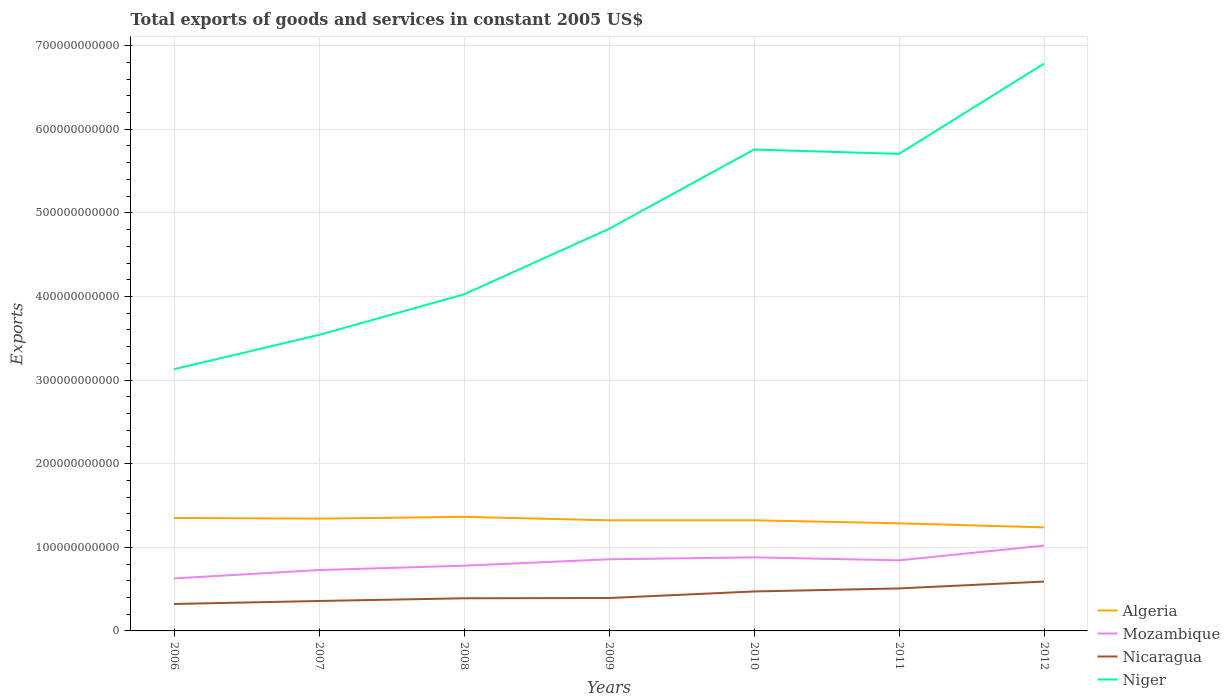How many different coloured lines are there?
Give a very brief answer. 4. Is the number of lines equal to the number of legend labels?
Keep it short and to the point. Yes. Across all years, what is the maximum total exports of goods and services in Mozambique?
Your response must be concise. 6.28e+1. What is the total total exports of goods and services in Niger in the graph?
Offer a terse response. 5.21e+09. What is the difference between the highest and the second highest total exports of goods and services in Algeria?
Provide a succinct answer. 1.26e+1. How many years are there in the graph?
Offer a very short reply. 7. What is the difference between two consecutive major ticks on the Y-axis?
Provide a short and direct response. 1.00e+11. Are the values on the major ticks of Y-axis written in scientific E-notation?
Keep it short and to the point. No. Where does the legend appear in the graph?
Ensure brevity in your answer.  Bottom right. How are the legend labels stacked?
Offer a terse response. Vertical. What is the title of the graph?
Offer a terse response. Total exports of goods and services in constant 2005 US$. Does "American Samoa" appear as one of the legend labels in the graph?
Your answer should be compact. No. What is the label or title of the X-axis?
Provide a short and direct response. Years. What is the label or title of the Y-axis?
Your answer should be compact. Exports. What is the Exports in Algeria in 2006?
Ensure brevity in your answer.  1.35e+11. What is the Exports of Mozambique in 2006?
Your response must be concise. 6.28e+1. What is the Exports of Nicaragua in 2006?
Offer a very short reply. 3.22e+1. What is the Exports in Niger in 2006?
Offer a very short reply. 3.13e+11. What is the Exports of Algeria in 2007?
Keep it short and to the point. 1.34e+11. What is the Exports of Mozambique in 2007?
Offer a very short reply. 7.28e+1. What is the Exports of Nicaragua in 2007?
Offer a terse response. 3.58e+1. What is the Exports of Niger in 2007?
Provide a succinct answer. 3.54e+11. What is the Exports of Algeria in 2008?
Give a very brief answer. 1.36e+11. What is the Exports of Mozambique in 2008?
Keep it short and to the point. 7.80e+1. What is the Exports in Nicaragua in 2008?
Your response must be concise. 3.90e+1. What is the Exports of Niger in 2008?
Offer a terse response. 4.03e+11. What is the Exports in Algeria in 2009?
Make the answer very short. 1.32e+11. What is the Exports in Mozambique in 2009?
Provide a short and direct response. 8.57e+1. What is the Exports in Nicaragua in 2009?
Ensure brevity in your answer.  3.93e+1. What is the Exports in Niger in 2009?
Ensure brevity in your answer.  4.81e+11. What is the Exports of Algeria in 2010?
Provide a short and direct response. 1.32e+11. What is the Exports of Mozambique in 2010?
Keep it short and to the point. 8.80e+1. What is the Exports in Nicaragua in 2010?
Your response must be concise. 4.72e+1. What is the Exports of Niger in 2010?
Give a very brief answer. 5.76e+11. What is the Exports of Algeria in 2011?
Your answer should be very brief. 1.29e+11. What is the Exports in Mozambique in 2011?
Your answer should be very brief. 8.45e+1. What is the Exports of Nicaragua in 2011?
Give a very brief answer. 5.08e+1. What is the Exports of Niger in 2011?
Ensure brevity in your answer.  5.71e+11. What is the Exports of Algeria in 2012?
Make the answer very short. 1.24e+11. What is the Exports of Mozambique in 2012?
Offer a terse response. 1.02e+11. What is the Exports in Nicaragua in 2012?
Provide a succinct answer. 5.90e+1. What is the Exports in Niger in 2012?
Offer a terse response. 6.78e+11. Across all years, what is the maximum Exports of Algeria?
Your answer should be compact. 1.36e+11. Across all years, what is the maximum Exports of Mozambique?
Provide a short and direct response. 1.02e+11. Across all years, what is the maximum Exports in Nicaragua?
Make the answer very short. 5.90e+1. Across all years, what is the maximum Exports in Niger?
Your response must be concise. 6.78e+11. Across all years, what is the minimum Exports of Algeria?
Give a very brief answer. 1.24e+11. Across all years, what is the minimum Exports in Mozambique?
Your response must be concise. 6.28e+1. Across all years, what is the minimum Exports in Nicaragua?
Your response must be concise. 3.22e+1. Across all years, what is the minimum Exports of Niger?
Offer a terse response. 3.13e+11. What is the total Exports in Algeria in the graph?
Provide a succinct answer. 9.23e+11. What is the total Exports in Mozambique in the graph?
Your response must be concise. 5.74e+11. What is the total Exports of Nicaragua in the graph?
Your response must be concise. 3.03e+11. What is the total Exports in Niger in the graph?
Offer a terse response. 3.38e+12. What is the difference between the Exports in Algeria in 2006 and that in 2007?
Keep it short and to the point. 8.11e+08. What is the difference between the Exports in Mozambique in 2006 and that in 2007?
Your response must be concise. -1.00e+1. What is the difference between the Exports of Nicaragua in 2006 and that in 2007?
Make the answer very short. -3.57e+09. What is the difference between the Exports of Niger in 2006 and that in 2007?
Your answer should be compact. -4.11e+1. What is the difference between the Exports of Algeria in 2006 and that in 2008?
Your answer should be very brief. -1.34e+09. What is the difference between the Exports of Mozambique in 2006 and that in 2008?
Offer a terse response. -1.52e+1. What is the difference between the Exports of Nicaragua in 2006 and that in 2008?
Your response must be concise. -6.80e+09. What is the difference between the Exports of Niger in 2006 and that in 2008?
Ensure brevity in your answer.  -8.96e+1. What is the difference between the Exports in Algeria in 2006 and that in 2009?
Provide a short and direct response. 2.81e+09. What is the difference between the Exports of Mozambique in 2006 and that in 2009?
Keep it short and to the point. -2.29e+1. What is the difference between the Exports in Nicaragua in 2006 and that in 2009?
Your response must be concise. -7.11e+09. What is the difference between the Exports of Niger in 2006 and that in 2009?
Provide a short and direct response. -1.68e+11. What is the difference between the Exports in Algeria in 2006 and that in 2010?
Offer a terse response. 2.81e+09. What is the difference between the Exports in Mozambique in 2006 and that in 2010?
Your response must be concise. -2.52e+1. What is the difference between the Exports in Nicaragua in 2006 and that in 2010?
Provide a succinct answer. -1.49e+1. What is the difference between the Exports in Niger in 2006 and that in 2010?
Ensure brevity in your answer.  -2.63e+11. What is the difference between the Exports of Algeria in 2006 and that in 2011?
Your answer should be very brief. 6.38e+09. What is the difference between the Exports of Mozambique in 2006 and that in 2011?
Keep it short and to the point. -2.17e+1. What is the difference between the Exports of Nicaragua in 2006 and that in 2011?
Ensure brevity in your answer.  -1.86e+1. What is the difference between the Exports of Niger in 2006 and that in 2011?
Keep it short and to the point. -2.58e+11. What is the difference between the Exports of Algeria in 2006 and that in 2012?
Make the answer very short. 1.13e+1. What is the difference between the Exports of Mozambique in 2006 and that in 2012?
Provide a short and direct response. -3.92e+1. What is the difference between the Exports in Nicaragua in 2006 and that in 2012?
Give a very brief answer. -2.68e+1. What is the difference between the Exports in Niger in 2006 and that in 2012?
Your answer should be very brief. -3.66e+11. What is the difference between the Exports of Algeria in 2007 and that in 2008?
Your answer should be compact. -2.15e+09. What is the difference between the Exports in Mozambique in 2007 and that in 2008?
Ensure brevity in your answer.  -5.20e+09. What is the difference between the Exports in Nicaragua in 2007 and that in 2008?
Make the answer very short. -3.23e+09. What is the difference between the Exports of Niger in 2007 and that in 2008?
Give a very brief answer. -4.85e+1. What is the difference between the Exports of Algeria in 2007 and that in 2009?
Offer a terse response. 2.00e+09. What is the difference between the Exports in Mozambique in 2007 and that in 2009?
Your answer should be very brief. -1.29e+1. What is the difference between the Exports in Nicaragua in 2007 and that in 2009?
Keep it short and to the point. -3.54e+09. What is the difference between the Exports in Niger in 2007 and that in 2009?
Offer a terse response. -1.27e+11. What is the difference between the Exports of Algeria in 2007 and that in 2010?
Give a very brief answer. 2.00e+09. What is the difference between the Exports in Mozambique in 2007 and that in 2010?
Give a very brief answer. -1.52e+1. What is the difference between the Exports in Nicaragua in 2007 and that in 2010?
Your response must be concise. -1.14e+1. What is the difference between the Exports in Niger in 2007 and that in 2010?
Offer a terse response. -2.22e+11. What is the difference between the Exports of Algeria in 2007 and that in 2011?
Your answer should be compact. 5.57e+09. What is the difference between the Exports of Mozambique in 2007 and that in 2011?
Make the answer very short. -1.17e+1. What is the difference between the Exports in Nicaragua in 2007 and that in 2011?
Your answer should be very brief. -1.50e+1. What is the difference between the Exports in Niger in 2007 and that in 2011?
Offer a very short reply. -2.16e+11. What is the difference between the Exports in Algeria in 2007 and that in 2012?
Your answer should be very brief. 1.05e+1. What is the difference between the Exports in Mozambique in 2007 and that in 2012?
Keep it short and to the point. -2.92e+1. What is the difference between the Exports in Nicaragua in 2007 and that in 2012?
Your answer should be very brief. -2.32e+1. What is the difference between the Exports of Niger in 2007 and that in 2012?
Your response must be concise. -3.24e+11. What is the difference between the Exports of Algeria in 2008 and that in 2009?
Provide a short and direct response. 4.15e+09. What is the difference between the Exports in Mozambique in 2008 and that in 2009?
Offer a very short reply. -7.68e+09. What is the difference between the Exports of Nicaragua in 2008 and that in 2009?
Offer a very short reply. -3.12e+08. What is the difference between the Exports of Niger in 2008 and that in 2009?
Ensure brevity in your answer.  -7.83e+1. What is the difference between the Exports of Algeria in 2008 and that in 2010?
Make the answer very short. 4.15e+09. What is the difference between the Exports of Mozambique in 2008 and that in 2010?
Your response must be concise. -1.00e+1. What is the difference between the Exports in Nicaragua in 2008 and that in 2010?
Provide a succinct answer. -8.14e+09. What is the difference between the Exports of Niger in 2008 and that in 2010?
Give a very brief answer. -1.73e+11. What is the difference between the Exports in Algeria in 2008 and that in 2011?
Provide a succinct answer. 7.72e+09. What is the difference between the Exports in Mozambique in 2008 and that in 2011?
Give a very brief answer. -6.46e+09. What is the difference between the Exports of Nicaragua in 2008 and that in 2011?
Offer a terse response. -1.18e+1. What is the difference between the Exports of Niger in 2008 and that in 2011?
Your answer should be compact. -1.68e+11. What is the difference between the Exports in Algeria in 2008 and that in 2012?
Make the answer very short. 1.26e+1. What is the difference between the Exports of Mozambique in 2008 and that in 2012?
Keep it short and to the point. -2.40e+1. What is the difference between the Exports in Nicaragua in 2008 and that in 2012?
Provide a succinct answer. -2.00e+1. What is the difference between the Exports of Niger in 2008 and that in 2012?
Your answer should be very brief. -2.76e+11. What is the difference between the Exports of Algeria in 2009 and that in 2010?
Ensure brevity in your answer.  0. What is the difference between the Exports in Mozambique in 2009 and that in 2010?
Keep it short and to the point. -2.32e+09. What is the difference between the Exports in Nicaragua in 2009 and that in 2010?
Offer a terse response. -7.83e+09. What is the difference between the Exports in Niger in 2009 and that in 2010?
Provide a succinct answer. -9.49e+1. What is the difference between the Exports of Algeria in 2009 and that in 2011?
Give a very brief answer. 3.57e+09. What is the difference between the Exports of Mozambique in 2009 and that in 2011?
Provide a succinct answer. 1.22e+09. What is the difference between the Exports in Nicaragua in 2009 and that in 2011?
Ensure brevity in your answer.  -1.15e+1. What is the difference between the Exports in Niger in 2009 and that in 2011?
Provide a succinct answer. -8.97e+1. What is the difference between the Exports in Algeria in 2009 and that in 2012?
Give a very brief answer. 8.46e+09. What is the difference between the Exports of Mozambique in 2009 and that in 2012?
Your answer should be very brief. -1.64e+1. What is the difference between the Exports in Nicaragua in 2009 and that in 2012?
Ensure brevity in your answer.  -1.97e+1. What is the difference between the Exports in Niger in 2009 and that in 2012?
Give a very brief answer. -1.98e+11. What is the difference between the Exports in Algeria in 2010 and that in 2011?
Provide a succinct answer. 3.57e+09. What is the difference between the Exports of Mozambique in 2010 and that in 2011?
Give a very brief answer. 3.54e+09. What is the difference between the Exports of Nicaragua in 2010 and that in 2011?
Provide a short and direct response. -3.65e+09. What is the difference between the Exports of Niger in 2010 and that in 2011?
Keep it short and to the point. 5.21e+09. What is the difference between the Exports in Algeria in 2010 and that in 2012?
Your answer should be compact. 8.46e+09. What is the difference between the Exports in Mozambique in 2010 and that in 2012?
Provide a short and direct response. -1.40e+1. What is the difference between the Exports of Nicaragua in 2010 and that in 2012?
Offer a terse response. -1.19e+1. What is the difference between the Exports in Niger in 2010 and that in 2012?
Keep it short and to the point. -1.03e+11. What is the difference between the Exports in Algeria in 2011 and that in 2012?
Offer a terse response. 4.89e+09. What is the difference between the Exports of Mozambique in 2011 and that in 2012?
Offer a very short reply. -1.76e+1. What is the difference between the Exports of Nicaragua in 2011 and that in 2012?
Provide a short and direct response. -8.22e+09. What is the difference between the Exports of Niger in 2011 and that in 2012?
Offer a very short reply. -1.08e+11. What is the difference between the Exports of Algeria in 2006 and the Exports of Mozambique in 2007?
Keep it short and to the point. 6.23e+1. What is the difference between the Exports in Algeria in 2006 and the Exports in Nicaragua in 2007?
Give a very brief answer. 9.93e+1. What is the difference between the Exports of Algeria in 2006 and the Exports of Niger in 2007?
Your answer should be very brief. -2.19e+11. What is the difference between the Exports of Mozambique in 2006 and the Exports of Nicaragua in 2007?
Provide a short and direct response. 2.70e+1. What is the difference between the Exports in Mozambique in 2006 and the Exports in Niger in 2007?
Your answer should be very brief. -2.91e+11. What is the difference between the Exports in Nicaragua in 2006 and the Exports in Niger in 2007?
Give a very brief answer. -3.22e+11. What is the difference between the Exports in Algeria in 2006 and the Exports in Mozambique in 2008?
Offer a very short reply. 5.71e+1. What is the difference between the Exports of Algeria in 2006 and the Exports of Nicaragua in 2008?
Ensure brevity in your answer.  9.61e+1. What is the difference between the Exports of Algeria in 2006 and the Exports of Niger in 2008?
Offer a very short reply. -2.67e+11. What is the difference between the Exports in Mozambique in 2006 and the Exports in Nicaragua in 2008?
Make the answer very short. 2.38e+1. What is the difference between the Exports in Mozambique in 2006 and the Exports in Niger in 2008?
Offer a terse response. -3.40e+11. What is the difference between the Exports of Nicaragua in 2006 and the Exports of Niger in 2008?
Make the answer very short. -3.70e+11. What is the difference between the Exports in Algeria in 2006 and the Exports in Mozambique in 2009?
Your answer should be very brief. 4.94e+1. What is the difference between the Exports of Algeria in 2006 and the Exports of Nicaragua in 2009?
Give a very brief answer. 9.58e+1. What is the difference between the Exports of Algeria in 2006 and the Exports of Niger in 2009?
Your answer should be very brief. -3.46e+11. What is the difference between the Exports of Mozambique in 2006 and the Exports of Nicaragua in 2009?
Your answer should be compact. 2.34e+1. What is the difference between the Exports of Mozambique in 2006 and the Exports of Niger in 2009?
Your answer should be very brief. -4.18e+11. What is the difference between the Exports in Nicaragua in 2006 and the Exports in Niger in 2009?
Offer a very short reply. -4.49e+11. What is the difference between the Exports of Algeria in 2006 and the Exports of Mozambique in 2010?
Provide a succinct answer. 4.71e+1. What is the difference between the Exports of Algeria in 2006 and the Exports of Nicaragua in 2010?
Your answer should be very brief. 8.79e+1. What is the difference between the Exports of Algeria in 2006 and the Exports of Niger in 2010?
Offer a terse response. -4.41e+11. What is the difference between the Exports in Mozambique in 2006 and the Exports in Nicaragua in 2010?
Make the answer very short. 1.56e+1. What is the difference between the Exports of Mozambique in 2006 and the Exports of Niger in 2010?
Provide a short and direct response. -5.13e+11. What is the difference between the Exports of Nicaragua in 2006 and the Exports of Niger in 2010?
Give a very brief answer. -5.43e+11. What is the difference between the Exports of Algeria in 2006 and the Exports of Mozambique in 2011?
Your response must be concise. 5.06e+1. What is the difference between the Exports in Algeria in 2006 and the Exports in Nicaragua in 2011?
Offer a terse response. 8.43e+1. What is the difference between the Exports in Algeria in 2006 and the Exports in Niger in 2011?
Your answer should be very brief. -4.35e+11. What is the difference between the Exports of Mozambique in 2006 and the Exports of Nicaragua in 2011?
Provide a short and direct response. 1.20e+1. What is the difference between the Exports of Mozambique in 2006 and the Exports of Niger in 2011?
Give a very brief answer. -5.08e+11. What is the difference between the Exports of Nicaragua in 2006 and the Exports of Niger in 2011?
Your answer should be compact. -5.38e+11. What is the difference between the Exports of Algeria in 2006 and the Exports of Mozambique in 2012?
Make the answer very short. 3.31e+1. What is the difference between the Exports of Algeria in 2006 and the Exports of Nicaragua in 2012?
Keep it short and to the point. 7.61e+1. What is the difference between the Exports in Algeria in 2006 and the Exports in Niger in 2012?
Give a very brief answer. -5.43e+11. What is the difference between the Exports of Mozambique in 2006 and the Exports of Nicaragua in 2012?
Provide a short and direct response. 3.75e+09. What is the difference between the Exports of Mozambique in 2006 and the Exports of Niger in 2012?
Your answer should be very brief. -6.16e+11. What is the difference between the Exports in Nicaragua in 2006 and the Exports in Niger in 2012?
Give a very brief answer. -6.46e+11. What is the difference between the Exports in Algeria in 2007 and the Exports in Mozambique in 2008?
Offer a very short reply. 5.63e+1. What is the difference between the Exports of Algeria in 2007 and the Exports of Nicaragua in 2008?
Your answer should be compact. 9.53e+1. What is the difference between the Exports of Algeria in 2007 and the Exports of Niger in 2008?
Ensure brevity in your answer.  -2.68e+11. What is the difference between the Exports in Mozambique in 2007 and the Exports in Nicaragua in 2008?
Make the answer very short. 3.38e+1. What is the difference between the Exports of Mozambique in 2007 and the Exports of Niger in 2008?
Give a very brief answer. -3.30e+11. What is the difference between the Exports of Nicaragua in 2007 and the Exports of Niger in 2008?
Give a very brief answer. -3.67e+11. What is the difference between the Exports of Algeria in 2007 and the Exports of Mozambique in 2009?
Make the answer very short. 4.86e+1. What is the difference between the Exports in Algeria in 2007 and the Exports in Nicaragua in 2009?
Your answer should be compact. 9.49e+1. What is the difference between the Exports in Algeria in 2007 and the Exports in Niger in 2009?
Give a very brief answer. -3.47e+11. What is the difference between the Exports in Mozambique in 2007 and the Exports in Nicaragua in 2009?
Offer a terse response. 3.34e+1. What is the difference between the Exports of Mozambique in 2007 and the Exports of Niger in 2009?
Make the answer very short. -4.08e+11. What is the difference between the Exports in Nicaragua in 2007 and the Exports in Niger in 2009?
Your answer should be compact. -4.45e+11. What is the difference between the Exports in Algeria in 2007 and the Exports in Mozambique in 2010?
Provide a short and direct response. 4.63e+1. What is the difference between the Exports of Algeria in 2007 and the Exports of Nicaragua in 2010?
Provide a short and direct response. 8.71e+1. What is the difference between the Exports in Algeria in 2007 and the Exports in Niger in 2010?
Make the answer very short. -4.41e+11. What is the difference between the Exports of Mozambique in 2007 and the Exports of Nicaragua in 2010?
Your answer should be compact. 2.56e+1. What is the difference between the Exports in Mozambique in 2007 and the Exports in Niger in 2010?
Offer a terse response. -5.03e+11. What is the difference between the Exports of Nicaragua in 2007 and the Exports of Niger in 2010?
Provide a succinct answer. -5.40e+11. What is the difference between the Exports in Algeria in 2007 and the Exports in Mozambique in 2011?
Your answer should be compact. 4.98e+1. What is the difference between the Exports in Algeria in 2007 and the Exports in Nicaragua in 2011?
Provide a short and direct response. 8.35e+1. What is the difference between the Exports in Algeria in 2007 and the Exports in Niger in 2011?
Make the answer very short. -4.36e+11. What is the difference between the Exports in Mozambique in 2007 and the Exports in Nicaragua in 2011?
Provide a succinct answer. 2.20e+1. What is the difference between the Exports of Mozambique in 2007 and the Exports of Niger in 2011?
Your answer should be compact. -4.98e+11. What is the difference between the Exports of Nicaragua in 2007 and the Exports of Niger in 2011?
Give a very brief answer. -5.35e+11. What is the difference between the Exports in Algeria in 2007 and the Exports in Mozambique in 2012?
Provide a succinct answer. 3.23e+1. What is the difference between the Exports of Algeria in 2007 and the Exports of Nicaragua in 2012?
Offer a terse response. 7.52e+1. What is the difference between the Exports in Algeria in 2007 and the Exports in Niger in 2012?
Your response must be concise. -5.44e+11. What is the difference between the Exports in Mozambique in 2007 and the Exports in Nicaragua in 2012?
Ensure brevity in your answer.  1.38e+1. What is the difference between the Exports in Mozambique in 2007 and the Exports in Niger in 2012?
Provide a succinct answer. -6.06e+11. What is the difference between the Exports in Nicaragua in 2007 and the Exports in Niger in 2012?
Your answer should be very brief. -6.43e+11. What is the difference between the Exports of Algeria in 2008 and the Exports of Mozambique in 2009?
Offer a terse response. 5.08e+1. What is the difference between the Exports in Algeria in 2008 and the Exports in Nicaragua in 2009?
Your response must be concise. 9.71e+1. What is the difference between the Exports of Algeria in 2008 and the Exports of Niger in 2009?
Make the answer very short. -3.44e+11. What is the difference between the Exports of Mozambique in 2008 and the Exports of Nicaragua in 2009?
Make the answer very short. 3.86e+1. What is the difference between the Exports of Mozambique in 2008 and the Exports of Niger in 2009?
Provide a short and direct response. -4.03e+11. What is the difference between the Exports in Nicaragua in 2008 and the Exports in Niger in 2009?
Offer a terse response. -4.42e+11. What is the difference between the Exports of Algeria in 2008 and the Exports of Mozambique in 2010?
Your answer should be very brief. 4.85e+1. What is the difference between the Exports of Algeria in 2008 and the Exports of Nicaragua in 2010?
Your answer should be compact. 8.93e+1. What is the difference between the Exports in Algeria in 2008 and the Exports in Niger in 2010?
Give a very brief answer. -4.39e+11. What is the difference between the Exports in Mozambique in 2008 and the Exports in Nicaragua in 2010?
Your answer should be very brief. 3.08e+1. What is the difference between the Exports in Mozambique in 2008 and the Exports in Niger in 2010?
Your answer should be very brief. -4.98e+11. What is the difference between the Exports of Nicaragua in 2008 and the Exports of Niger in 2010?
Keep it short and to the point. -5.37e+11. What is the difference between the Exports of Algeria in 2008 and the Exports of Mozambique in 2011?
Give a very brief answer. 5.20e+1. What is the difference between the Exports in Algeria in 2008 and the Exports in Nicaragua in 2011?
Make the answer very short. 8.56e+1. What is the difference between the Exports in Algeria in 2008 and the Exports in Niger in 2011?
Provide a short and direct response. -4.34e+11. What is the difference between the Exports in Mozambique in 2008 and the Exports in Nicaragua in 2011?
Give a very brief answer. 2.72e+1. What is the difference between the Exports in Mozambique in 2008 and the Exports in Niger in 2011?
Ensure brevity in your answer.  -4.93e+11. What is the difference between the Exports of Nicaragua in 2008 and the Exports of Niger in 2011?
Provide a succinct answer. -5.31e+11. What is the difference between the Exports in Algeria in 2008 and the Exports in Mozambique in 2012?
Offer a very short reply. 3.44e+1. What is the difference between the Exports in Algeria in 2008 and the Exports in Nicaragua in 2012?
Give a very brief answer. 7.74e+1. What is the difference between the Exports of Algeria in 2008 and the Exports of Niger in 2012?
Offer a terse response. -5.42e+11. What is the difference between the Exports in Mozambique in 2008 and the Exports in Nicaragua in 2012?
Ensure brevity in your answer.  1.89e+1. What is the difference between the Exports of Mozambique in 2008 and the Exports of Niger in 2012?
Offer a terse response. -6.01e+11. What is the difference between the Exports in Nicaragua in 2008 and the Exports in Niger in 2012?
Offer a terse response. -6.39e+11. What is the difference between the Exports in Algeria in 2009 and the Exports in Mozambique in 2010?
Keep it short and to the point. 4.43e+1. What is the difference between the Exports of Algeria in 2009 and the Exports of Nicaragua in 2010?
Offer a terse response. 8.51e+1. What is the difference between the Exports in Algeria in 2009 and the Exports in Niger in 2010?
Keep it short and to the point. -4.43e+11. What is the difference between the Exports of Mozambique in 2009 and the Exports of Nicaragua in 2010?
Offer a terse response. 3.85e+1. What is the difference between the Exports in Mozambique in 2009 and the Exports in Niger in 2010?
Make the answer very short. -4.90e+11. What is the difference between the Exports in Nicaragua in 2009 and the Exports in Niger in 2010?
Make the answer very short. -5.36e+11. What is the difference between the Exports of Algeria in 2009 and the Exports of Mozambique in 2011?
Your response must be concise. 4.78e+1. What is the difference between the Exports in Algeria in 2009 and the Exports in Nicaragua in 2011?
Your answer should be very brief. 8.15e+1. What is the difference between the Exports in Algeria in 2009 and the Exports in Niger in 2011?
Provide a short and direct response. -4.38e+11. What is the difference between the Exports in Mozambique in 2009 and the Exports in Nicaragua in 2011?
Your answer should be compact. 3.48e+1. What is the difference between the Exports in Mozambique in 2009 and the Exports in Niger in 2011?
Give a very brief answer. -4.85e+11. What is the difference between the Exports in Nicaragua in 2009 and the Exports in Niger in 2011?
Ensure brevity in your answer.  -5.31e+11. What is the difference between the Exports in Algeria in 2009 and the Exports in Mozambique in 2012?
Keep it short and to the point. 3.03e+1. What is the difference between the Exports of Algeria in 2009 and the Exports of Nicaragua in 2012?
Your answer should be very brief. 7.32e+1. What is the difference between the Exports of Algeria in 2009 and the Exports of Niger in 2012?
Provide a short and direct response. -5.46e+11. What is the difference between the Exports of Mozambique in 2009 and the Exports of Nicaragua in 2012?
Offer a very short reply. 2.66e+1. What is the difference between the Exports in Mozambique in 2009 and the Exports in Niger in 2012?
Provide a short and direct response. -5.93e+11. What is the difference between the Exports in Nicaragua in 2009 and the Exports in Niger in 2012?
Provide a succinct answer. -6.39e+11. What is the difference between the Exports of Algeria in 2010 and the Exports of Mozambique in 2011?
Offer a terse response. 4.78e+1. What is the difference between the Exports of Algeria in 2010 and the Exports of Nicaragua in 2011?
Provide a short and direct response. 8.15e+1. What is the difference between the Exports of Algeria in 2010 and the Exports of Niger in 2011?
Keep it short and to the point. -4.38e+11. What is the difference between the Exports of Mozambique in 2010 and the Exports of Nicaragua in 2011?
Give a very brief answer. 3.72e+1. What is the difference between the Exports of Mozambique in 2010 and the Exports of Niger in 2011?
Your answer should be very brief. -4.83e+11. What is the difference between the Exports in Nicaragua in 2010 and the Exports in Niger in 2011?
Make the answer very short. -5.23e+11. What is the difference between the Exports of Algeria in 2010 and the Exports of Mozambique in 2012?
Give a very brief answer. 3.03e+1. What is the difference between the Exports in Algeria in 2010 and the Exports in Nicaragua in 2012?
Make the answer very short. 7.32e+1. What is the difference between the Exports of Algeria in 2010 and the Exports of Niger in 2012?
Make the answer very short. -5.46e+11. What is the difference between the Exports in Mozambique in 2010 and the Exports in Nicaragua in 2012?
Give a very brief answer. 2.89e+1. What is the difference between the Exports in Mozambique in 2010 and the Exports in Niger in 2012?
Provide a succinct answer. -5.91e+11. What is the difference between the Exports in Nicaragua in 2010 and the Exports in Niger in 2012?
Offer a very short reply. -6.31e+11. What is the difference between the Exports in Algeria in 2011 and the Exports in Mozambique in 2012?
Provide a short and direct response. 2.67e+1. What is the difference between the Exports of Algeria in 2011 and the Exports of Nicaragua in 2012?
Provide a succinct answer. 6.97e+1. What is the difference between the Exports of Algeria in 2011 and the Exports of Niger in 2012?
Make the answer very short. -5.50e+11. What is the difference between the Exports of Mozambique in 2011 and the Exports of Nicaragua in 2012?
Give a very brief answer. 2.54e+1. What is the difference between the Exports in Mozambique in 2011 and the Exports in Niger in 2012?
Provide a succinct answer. -5.94e+11. What is the difference between the Exports of Nicaragua in 2011 and the Exports of Niger in 2012?
Give a very brief answer. -6.28e+11. What is the average Exports of Algeria per year?
Your response must be concise. 1.32e+11. What is the average Exports in Mozambique per year?
Provide a short and direct response. 8.20e+1. What is the average Exports of Nicaragua per year?
Give a very brief answer. 4.34e+1. What is the average Exports of Niger per year?
Make the answer very short. 4.82e+11. In the year 2006, what is the difference between the Exports in Algeria and Exports in Mozambique?
Ensure brevity in your answer.  7.23e+1. In the year 2006, what is the difference between the Exports in Algeria and Exports in Nicaragua?
Give a very brief answer. 1.03e+11. In the year 2006, what is the difference between the Exports in Algeria and Exports in Niger?
Provide a succinct answer. -1.78e+11. In the year 2006, what is the difference between the Exports in Mozambique and Exports in Nicaragua?
Offer a very short reply. 3.06e+1. In the year 2006, what is the difference between the Exports of Mozambique and Exports of Niger?
Offer a very short reply. -2.50e+11. In the year 2006, what is the difference between the Exports in Nicaragua and Exports in Niger?
Give a very brief answer. -2.81e+11. In the year 2007, what is the difference between the Exports in Algeria and Exports in Mozambique?
Offer a very short reply. 6.15e+1. In the year 2007, what is the difference between the Exports of Algeria and Exports of Nicaragua?
Your answer should be very brief. 9.85e+1. In the year 2007, what is the difference between the Exports in Algeria and Exports in Niger?
Ensure brevity in your answer.  -2.20e+11. In the year 2007, what is the difference between the Exports in Mozambique and Exports in Nicaragua?
Make the answer very short. 3.70e+1. In the year 2007, what is the difference between the Exports of Mozambique and Exports of Niger?
Ensure brevity in your answer.  -2.81e+11. In the year 2007, what is the difference between the Exports of Nicaragua and Exports of Niger?
Offer a terse response. -3.18e+11. In the year 2008, what is the difference between the Exports of Algeria and Exports of Mozambique?
Ensure brevity in your answer.  5.84e+1. In the year 2008, what is the difference between the Exports in Algeria and Exports in Nicaragua?
Keep it short and to the point. 9.74e+1. In the year 2008, what is the difference between the Exports in Algeria and Exports in Niger?
Give a very brief answer. -2.66e+11. In the year 2008, what is the difference between the Exports in Mozambique and Exports in Nicaragua?
Provide a short and direct response. 3.90e+1. In the year 2008, what is the difference between the Exports of Mozambique and Exports of Niger?
Provide a succinct answer. -3.25e+11. In the year 2008, what is the difference between the Exports of Nicaragua and Exports of Niger?
Your response must be concise. -3.64e+11. In the year 2009, what is the difference between the Exports in Algeria and Exports in Mozambique?
Your answer should be very brief. 4.66e+1. In the year 2009, what is the difference between the Exports of Algeria and Exports of Nicaragua?
Your response must be concise. 9.29e+1. In the year 2009, what is the difference between the Exports of Algeria and Exports of Niger?
Keep it short and to the point. -3.49e+11. In the year 2009, what is the difference between the Exports in Mozambique and Exports in Nicaragua?
Give a very brief answer. 4.63e+1. In the year 2009, what is the difference between the Exports of Mozambique and Exports of Niger?
Keep it short and to the point. -3.95e+11. In the year 2009, what is the difference between the Exports of Nicaragua and Exports of Niger?
Provide a short and direct response. -4.42e+11. In the year 2010, what is the difference between the Exports of Algeria and Exports of Mozambique?
Your answer should be very brief. 4.43e+1. In the year 2010, what is the difference between the Exports in Algeria and Exports in Nicaragua?
Your response must be concise. 8.51e+1. In the year 2010, what is the difference between the Exports in Algeria and Exports in Niger?
Offer a very short reply. -4.43e+11. In the year 2010, what is the difference between the Exports in Mozambique and Exports in Nicaragua?
Ensure brevity in your answer.  4.08e+1. In the year 2010, what is the difference between the Exports in Mozambique and Exports in Niger?
Give a very brief answer. -4.88e+11. In the year 2010, what is the difference between the Exports in Nicaragua and Exports in Niger?
Provide a short and direct response. -5.29e+11. In the year 2011, what is the difference between the Exports in Algeria and Exports in Mozambique?
Provide a succinct answer. 4.43e+1. In the year 2011, what is the difference between the Exports of Algeria and Exports of Nicaragua?
Provide a short and direct response. 7.79e+1. In the year 2011, what is the difference between the Exports of Algeria and Exports of Niger?
Ensure brevity in your answer.  -4.42e+11. In the year 2011, what is the difference between the Exports in Mozambique and Exports in Nicaragua?
Keep it short and to the point. 3.36e+1. In the year 2011, what is the difference between the Exports of Mozambique and Exports of Niger?
Keep it short and to the point. -4.86e+11. In the year 2011, what is the difference between the Exports in Nicaragua and Exports in Niger?
Provide a succinct answer. -5.20e+11. In the year 2012, what is the difference between the Exports of Algeria and Exports of Mozambique?
Provide a succinct answer. 2.18e+1. In the year 2012, what is the difference between the Exports of Algeria and Exports of Nicaragua?
Your answer should be compact. 6.48e+1. In the year 2012, what is the difference between the Exports in Algeria and Exports in Niger?
Make the answer very short. -5.55e+11. In the year 2012, what is the difference between the Exports of Mozambique and Exports of Nicaragua?
Your answer should be very brief. 4.30e+1. In the year 2012, what is the difference between the Exports in Mozambique and Exports in Niger?
Your answer should be very brief. -5.76e+11. In the year 2012, what is the difference between the Exports in Nicaragua and Exports in Niger?
Your answer should be compact. -6.19e+11. What is the ratio of the Exports of Algeria in 2006 to that in 2007?
Offer a very short reply. 1.01. What is the ratio of the Exports in Mozambique in 2006 to that in 2007?
Offer a terse response. 0.86. What is the ratio of the Exports of Nicaragua in 2006 to that in 2007?
Provide a succinct answer. 0.9. What is the ratio of the Exports of Niger in 2006 to that in 2007?
Offer a terse response. 0.88. What is the ratio of the Exports of Algeria in 2006 to that in 2008?
Your response must be concise. 0.99. What is the ratio of the Exports of Mozambique in 2006 to that in 2008?
Provide a succinct answer. 0.81. What is the ratio of the Exports in Nicaragua in 2006 to that in 2008?
Give a very brief answer. 0.83. What is the ratio of the Exports in Niger in 2006 to that in 2008?
Offer a terse response. 0.78. What is the ratio of the Exports of Algeria in 2006 to that in 2009?
Make the answer very short. 1.02. What is the ratio of the Exports of Mozambique in 2006 to that in 2009?
Offer a terse response. 0.73. What is the ratio of the Exports in Nicaragua in 2006 to that in 2009?
Your response must be concise. 0.82. What is the ratio of the Exports of Niger in 2006 to that in 2009?
Provide a short and direct response. 0.65. What is the ratio of the Exports of Algeria in 2006 to that in 2010?
Give a very brief answer. 1.02. What is the ratio of the Exports in Mozambique in 2006 to that in 2010?
Keep it short and to the point. 0.71. What is the ratio of the Exports in Nicaragua in 2006 to that in 2010?
Offer a very short reply. 0.68. What is the ratio of the Exports of Niger in 2006 to that in 2010?
Offer a terse response. 0.54. What is the ratio of the Exports of Algeria in 2006 to that in 2011?
Provide a short and direct response. 1.05. What is the ratio of the Exports in Mozambique in 2006 to that in 2011?
Provide a succinct answer. 0.74. What is the ratio of the Exports of Nicaragua in 2006 to that in 2011?
Ensure brevity in your answer.  0.63. What is the ratio of the Exports of Niger in 2006 to that in 2011?
Give a very brief answer. 0.55. What is the ratio of the Exports in Algeria in 2006 to that in 2012?
Ensure brevity in your answer.  1.09. What is the ratio of the Exports of Mozambique in 2006 to that in 2012?
Offer a terse response. 0.62. What is the ratio of the Exports in Nicaragua in 2006 to that in 2012?
Offer a terse response. 0.55. What is the ratio of the Exports of Niger in 2006 to that in 2012?
Provide a short and direct response. 0.46. What is the ratio of the Exports of Algeria in 2007 to that in 2008?
Provide a succinct answer. 0.98. What is the ratio of the Exports of Mozambique in 2007 to that in 2008?
Provide a succinct answer. 0.93. What is the ratio of the Exports in Nicaragua in 2007 to that in 2008?
Offer a terse response. 0.92. What is the ratio of the Exports in Niger in 2007 to that in 2008?
Keep it short and to the point. 0.88. What is the ratio of the Exports in Algeria in 2007 to that in 2009?
Provide a short and direct response. 1.02. What is the ratio of the Exports of Mozambique in 2007 to that in 2009?
Make the answer very short. 0.85. What is the ratio of the Exports in Nicaragua in 2007 to that in 2009?
Provide a short and direct response. 0.91. What is the ratio of the Exports in Niger in 2007 to that in 2009?
Offer a terse response. 0.74. What is the ratio of the Exports in Algeria in 2007 to that in 2010?
Provide a short and direct response. 1.02. What is the ratio of the Exports in Mozambique in 2007 to that in 2010?
Offer a very short reply. 0.83. What is the ratio of the Exports in Nicaragua in 2007 to that in 2010?
Ensure brevity in your answer.  0.76. What is the ratio of the Exports in Niger in 2007 to that in 2010?
Keep it short and to the point. 0.61. What is the ratio of the Exports of Algeria in 2007 to that in 2011?
Give a very brief answer. 1.04. What is the ratio of the Exports in Mozambique in 2007 to that in 2011?
Your answer should be compact. 0.86. What is the ratio of the Exports of Nicaragua in 2007 to that in 2011?
Make the answer very short. 0.7. What is the ratio of the Exports in Niger in 2007 to that in 2011?
Give a very brief answer. 0.62. What is the ratio of the Exports in Algeria in 2007 to that in 2012?
Ensure brevity in your answer.  1.08. What is the ratio of the Exports of Mozambique in 2007 to that in 2012?
Ensure brevity in your answer.  0.71. What is the ratio of the Exports in Nicaragua in 2007 to that in 2012?
Offer a very short reply. 0.61. What is the ratio of the Exports in Niger in 2007 to that in 2012?
Provide a succinct answer. 0.52. What is the ratio of the Exports in Algeria in 2008 to that in 2009?
Give a very brief answer. 1.03. What is the ratio of the Exports in Mozambique in 2008 to that in 2009?
Ensure brevity in your answer.  0.91. What is the ratio of the Exports in Nicaragua in 2008 to that in 2009?
Provide a short and direct response. 0.99. What is the ratio of the Exports of Niger in 2008 to that in 2009?
Offer a very short reply. 0.84. What is the ratio of the Exports of Algeria in 2008 to that in 2010?
Ensure brevity in your answer.  1.03. What is the ratio of the Exports in Mozambique in 2008 to that in 2010?
Offer a terse response. 0.89. What is the ratio of the Exports of Nicaragua in 2008 to that in 2010?
Ensure brevity in your answer.  0.83. What is the ratio of the Exports in Niger in 2008 to that in 2010?
Your response must be concise. 0.7. What is the ratio of the Exports in Algeria in 2008 to that in 2011?
Give a very brief answer. 1.06. What is the ratio of the Exports in Mozambique in 2008 to that in 2011?
Make the answer very short. 0.92. What is the ratio of the Exports of Nicaragua in 2008 to that in 2011?
Your answer should be compact. 0.77. What is the ratio of the Exports in Niger in 2008 to that in 2011?
Your answer should be very brief. 0.71. What is the ratio of the Exports of Algeria in 2008 to that in 2012?
Your answer should be compact. 1.1. What is the ratio of the Exports in Mozambique in 2008 to that in 2012?
Your answer should be very brief. 0.76. What is the ratio of the Exports of Nicaragua in 2008 to that in 2012?
Ensure brevity in your answer.  0.66. What is the ratio of the Exports in Niger in 2008 to that in 2012?
Offer a terse response. 0.59. What is the ratio of the Exports of Algeria in 2009 to that in 2010?
Your answer should be very brief. 1. What is the ratio of the Exports in Mozambique in 2009 to that in 2010?
Offer a terse response. 0.97. What is the ratio of the Exports in Nicaragua in 2009 to that in 2010?
Your answer should be very brief. 0.83. What is the ratio of the Exports in Niger in 2009 to that in 2010?
Ensure brevity in your answer.  0.84. What is the ratio of the Exports in Algeria in 2009 to that in 2011?
Offer a terse response. 1.03. What is the ratio of the Exports of Mozambique in 2009 to that in 2011?
Give a very brief answer. 1.01. What is the ratio of the Exports of Nicaragua in 2009 to that in 2011?
Make the answer very short. 0.77. What is the ratio of the Exports of Niger in 2009 to that in 2011?
Provide a succinct answer. 0.84. What is the ratio of the Exports in Algeria in 2009 to that in 2012?
Provide a succinct answer. 1.07. What is the ratio of the Exports in Mozambique in 2009 to that in 2012?
Your response must be concise. 0.84. What is the ratio of the Exports in Nicaragua in 2009 to that in 2012?
Ensure brevity in your answer.  0.67. What is the ratio of the Exports in Niger in 2009 to that in 2012?
Ensure brevity in your answer.  0.71. What is the ratio of the Exports of Algeria in 2010 to that in 2011?
Give a very brief answer. 1.03. What is the ratio of the Exports in Mozambique in 2010 to that in 2011?
Your response must be concise. 1.04. What is the ratio of the Exports of Nicaragua in 2010 to that in 2011?
Provide a succinct answer. 0.93. What is the ratio of the Exports in Niger in 2010 to that in 2011?
Keep it short and to the point. 1.01. What is the ratio of the Exports in Algeria in 2010 to that in 2012?
Offer a terse response. 1.07. What is the ratio of the Exports of Mozambique in 2010 to that in 2012?
Your answer should be compact. 0.86. What is the ratio of the Exports of Nicaragua in 2010 to that in 2012?
Your response must be concise. 0.8. What is the ratio of the Exports of Niger in 2010 to that in 2012?
Keep it short and to the point. 0.85. What is the ratio of the Exports of Algeria in 2011 to that in 2012?
Ensure brevity in your answer.  1.04. What is the ratio of the Exports of Mozambique in 2011 to that in 2012?
Your response must be concise. 0.83. What is the ratio of the Exports of Nicaragua in 2011 to that in 2012?
Keep it short and to the point. 0.86. What is the ratio of the Exports of Niger in 2011 to that in 2012?
Make the answer very short. 0.84. What is the difference between the highest and the second highest Exports in Algeria?
Keep it short and to the point. 1.34e+09. What is the difference between the highest and the second highest Exports of Mozambique?
Make the answer very short. 1.40e+1. What is the difference between the highest and the second highest Exports in Nicaragua?
Keep it short and to the point. 8.22e+09. What is the difference between the highest and the second highest Exports in Niger?
Your answer should be very brief. 1.03e+11. What is the difference between the highest and the lowest Exports of Algeria?
Give a very brief answer. 1.26e+1. What is the difference between the highest and the lowest Exports of Mozambique?
Ensure brevity in your answer.  3.92e+1. What is the difference between the highest and the lowest Exports of Nicaragua?
Ensure brevity in your answer.  2.68e+1. What is the difference between the highest and the lowest Exports of Niger?
Ensure brevity in your answer.  3.66e+11. 